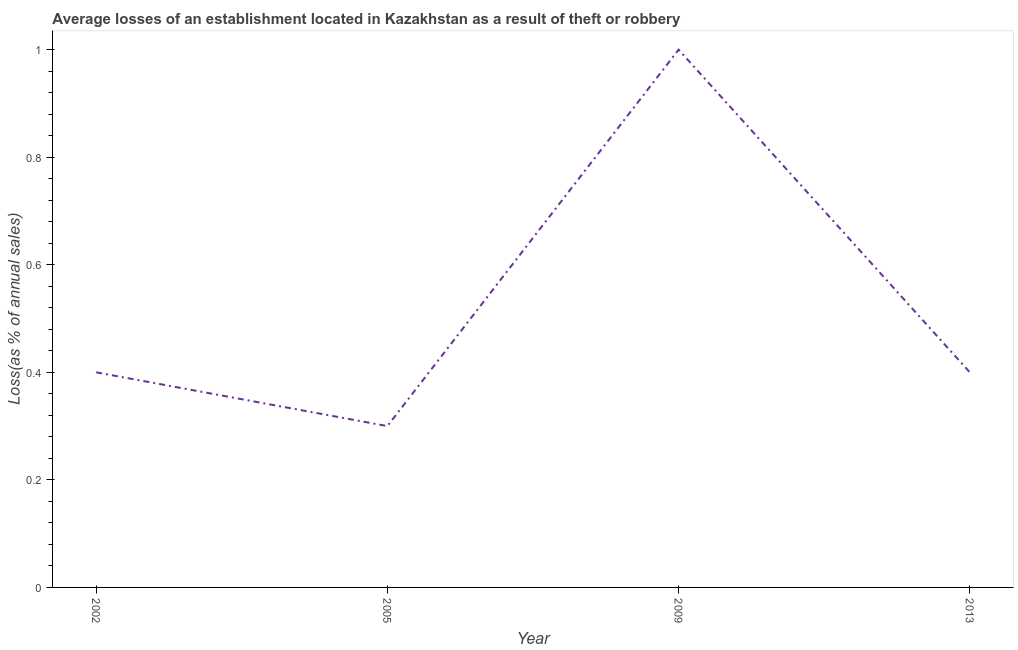What is the losses due to theft in 2013?
Make the answer very short. 0.4. Across all years, what is the minimum losses due to theft?
Your response must be concise. 0.3. What is the sum of the losses due to theft?
Keep it short and to the point. 2.1. What is the difference between the losses due to theft in 2002 and 2009?
Offer a very short reply. -0.6. What is the average losses due to theft per year?
Give a very brief answer. 0.53. What is the median losses due to theft?
Your answer should be compact. 0.4. What is the ratio of the losses due to theft in 2002 to that in 2005?
Offer a very short reply. 1.33. What is the difference between the highest and the lowest losses due to theft?
Your answer should be very brief. 0.7. What is the title of the graph?
Keep it short and to the point. Average losses of an establishment located in Kazakhstan as a result of theft or robbery. What is the label or title of the Y-axis?
Offer a terse response. Loss(as % of annual sales). What is the Loss(as % of annual sales) in 2002?
Offer a terse response. 0.4. What is the Loss(as % of annual sales) of 2013?
Ensure brevity in your answer.  0.4. What is the difference between the Loss(as % of annual sales) in 2002 and 2005?
Provide a succinct answer. 0.1. What is the difference between the Loss(as % of annual sales) in 2002 and 2009?
Your answer should be very brief. -0.6. What is the difference between the Loss(as % of annual sales) in 2002 and 2013?
Keep it short and to the point. 0. What is the difference between the Loss(as % of annual sales) in 2005 and 2009?
Offer a terse response. -0.7. What is the difference between the Loss(as % of annual sales) in 2005 and 2013?
Your answer should be very brief. -0.1. What is the difference between the Loss(as % of annual sales) in 2009 and 2013?
Your response must be concise. 0.6. What is the ratio of the Loss(as % of annual sales) in 2002 to that in 2005?
Provide a short and direct response. 1.33. What is the ratio of the Loss(as % of annual sales) in 2002 to that in 2013?
Keep it short and to the point. 1. What is the ratio of the Loss(as % of annual sales) in 2005 to that in 2009?
Your response must be concise. 0.3. 